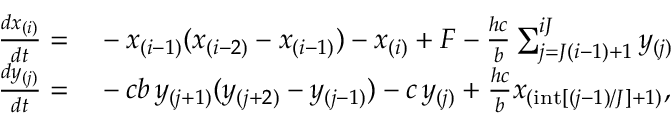<formula> <loc_0><loc_0><loc_500><loc_500>\begin{array} { r l } { \frac { d x _ { ( i ) } } { d t } = } & - x _ { ( i - 1 ) } ( x _ { ( i - 2 ) } - x _ { ( i - 1 ) } ) - x _ { ( i ) } + F - \frac { h c } { b } \sum _ { j = J ( i - 1 ) + 1 } ^ { i J } y _ { ( j ) } } \\ { \frac { d y _ { ( j ) } } { d t } = } & - c b \, y _ { ( j + 1 ) } ( y _ { ( j + 2 ) } - y _ { ( j - 1 ) } ) - c \, y _ { ( j ) } + \frac { h c } { b } x _ { ( i n t [ ( j - 1 ) / J ] + 1 ) } , } \end{array}</formula> 